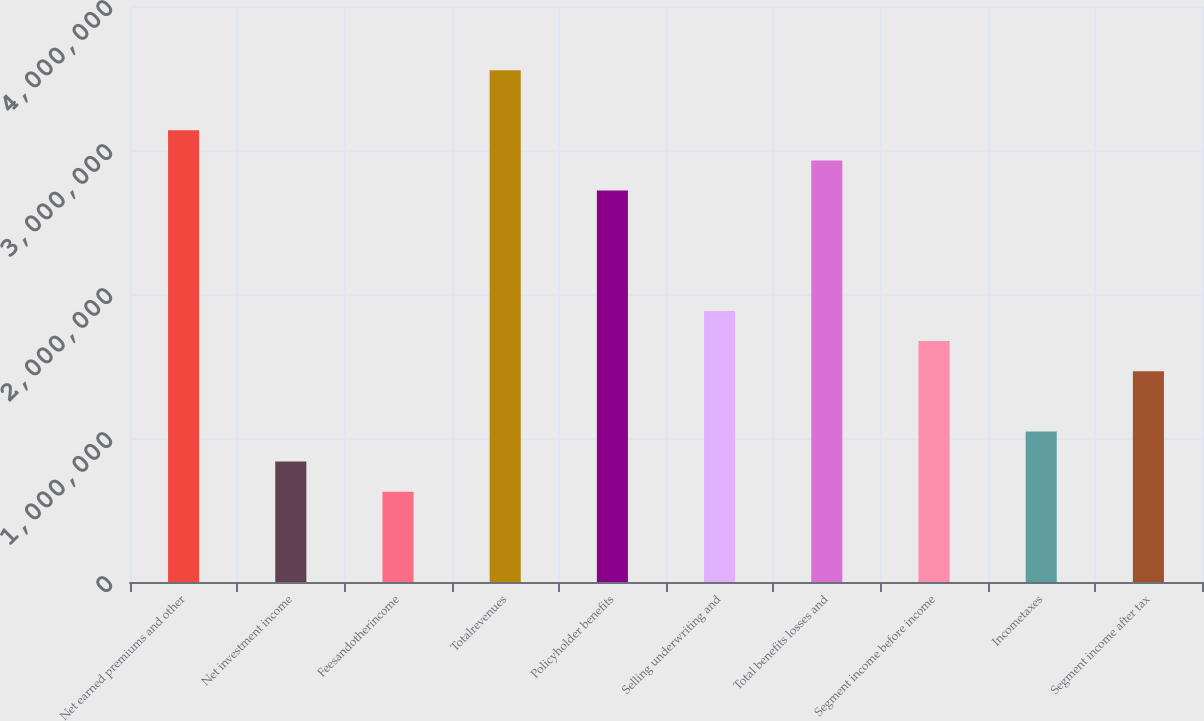<chart> <loc_0><loc_0><loc_500><loc_500><bar_chart><fcel>Net earned premiums and other<fcel>Net investment income<fcel>Feesandotherincome<fcel>Totalrevenues<fcel>Policyholder benefits<fcel>Selling underwriting and<fcel>Total benefits losses and<fcel>Segment income before income<fcel>Incometaxes<fcel>Segment income after tax<nl><fcel>3.13639e+06<fcel>836391<fcel>627300<fcel>3.55457e+06<fcel>2.7182e+06<fcel>1.88184e+06<fcel>2.92729e+06<fcel>1.67275e+06<fcel>1.04548e+06<fcel>1.46366e+06<nl></chart> 